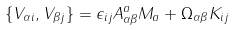<formula> <loc_0><loc_0><loc_500><loc_500>\{ V _ { \alpha i } , V _ { \beta j } \} = \epsilon _ { i j } A ^ { a } _ { \alpha \beta } M _ { a } + \Omega _ { \alpha \beta } K _ { i j }</formula> 